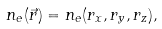<formula> <loc_0><loc_0><loc_500><loc_500>n _ { e } ( \vec { r } ) = n _ { e } ( r _ { x } , r _ { y } , r _ { z } ) ,</formula> 